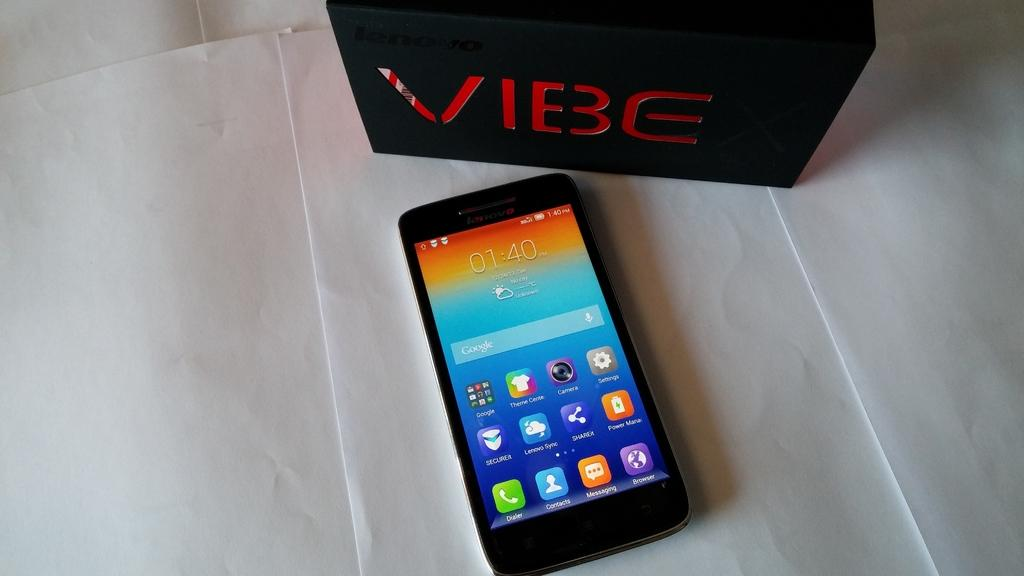<image>
Present a compact description of the photo's key features. A VIBE box sits next to a cell phone on the table. 